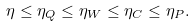<formula> <loc_0><loc_0><loc_500><loc_500>\eta \leq \eta _ { Q } \leq \eta _ { W } \leq \eta _ { C } \leq \eta _ { P } .</formula> 